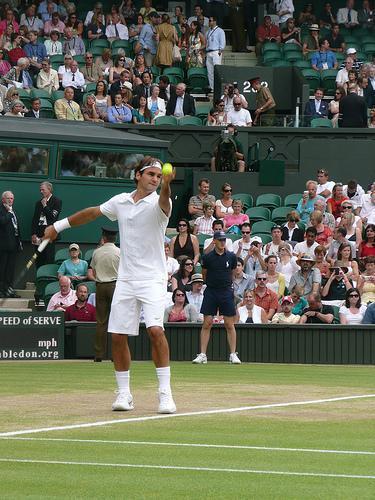How many players holding a racket?
Give a very brief answer. 1. 